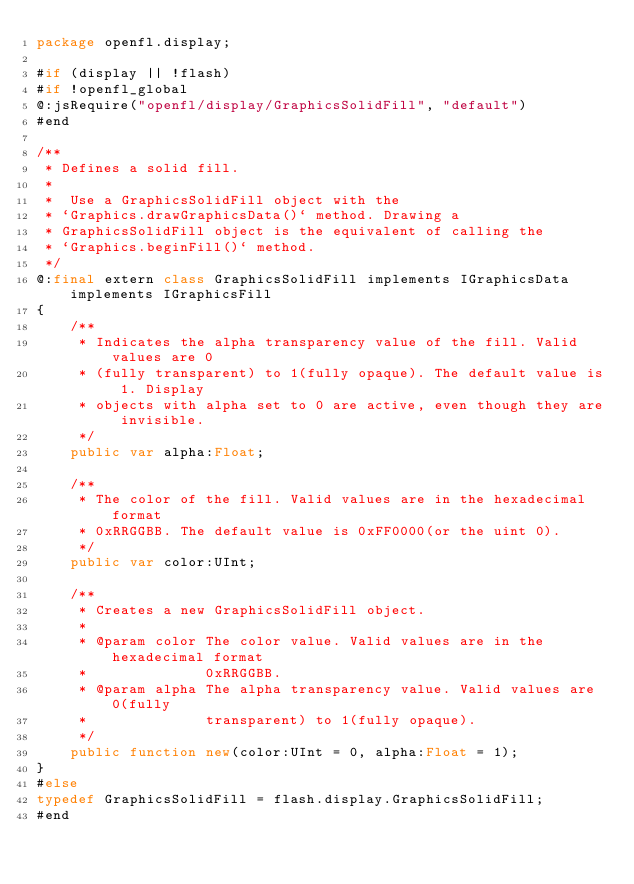<code> <loc_0><loc_0><loc_500><loc_500><_Haxe_>package openfl.display;

#if (display || !flash)
#if !openfl_global
@:jsRequire("openfl/display/GraphicsSolidFill", "default")
#end

/**
 * Defines a solid fill.
 *
 *  Use a GraphicsSolidFill object with the
 * `Graphics.drawGraphicsData()` method. Drawing a
 * GraphicsSolidFill object is the equivalent of calling the
 * `Graphics.beginFill()` method.
 */
@:final extern class GraphicsSolidFill implements IGraphicsData implements IGraphicsFill
{
	/**
	 * Indicates the alpha transparency value of the fill. Valid values are 0
	 * (fully transparent) to 1(fully opaque). The default value is 1. Display
	 * objects with alpha set to 0 are active, even though they are invisible.
	 */
	public var alpha:Float;

	/**
	 * The color of the fill. Valid values are in the hexadecimal format
	 * 0xRRGGBB. The default value is 0xFF0000(or the uint 0).
	 */
	public var color:UInt;

	/**
	 * Creates a new GraphicsSolidFill object.
	 *
	 * @param color The color value. Valid values are in the hexadecimal format
	 *              0xRRGGBB.
	 * @param alpha The alpha transparency value. Valid values are 0(fully
	 *              transparent) to 1(fully opaque).
	 */
	public function new(color:UInt = 0, alpha:Float = 1);
}
#else
typedef GraphicsSolidFill = flash.display.GraphicsSolidFill;
#end
</code> 